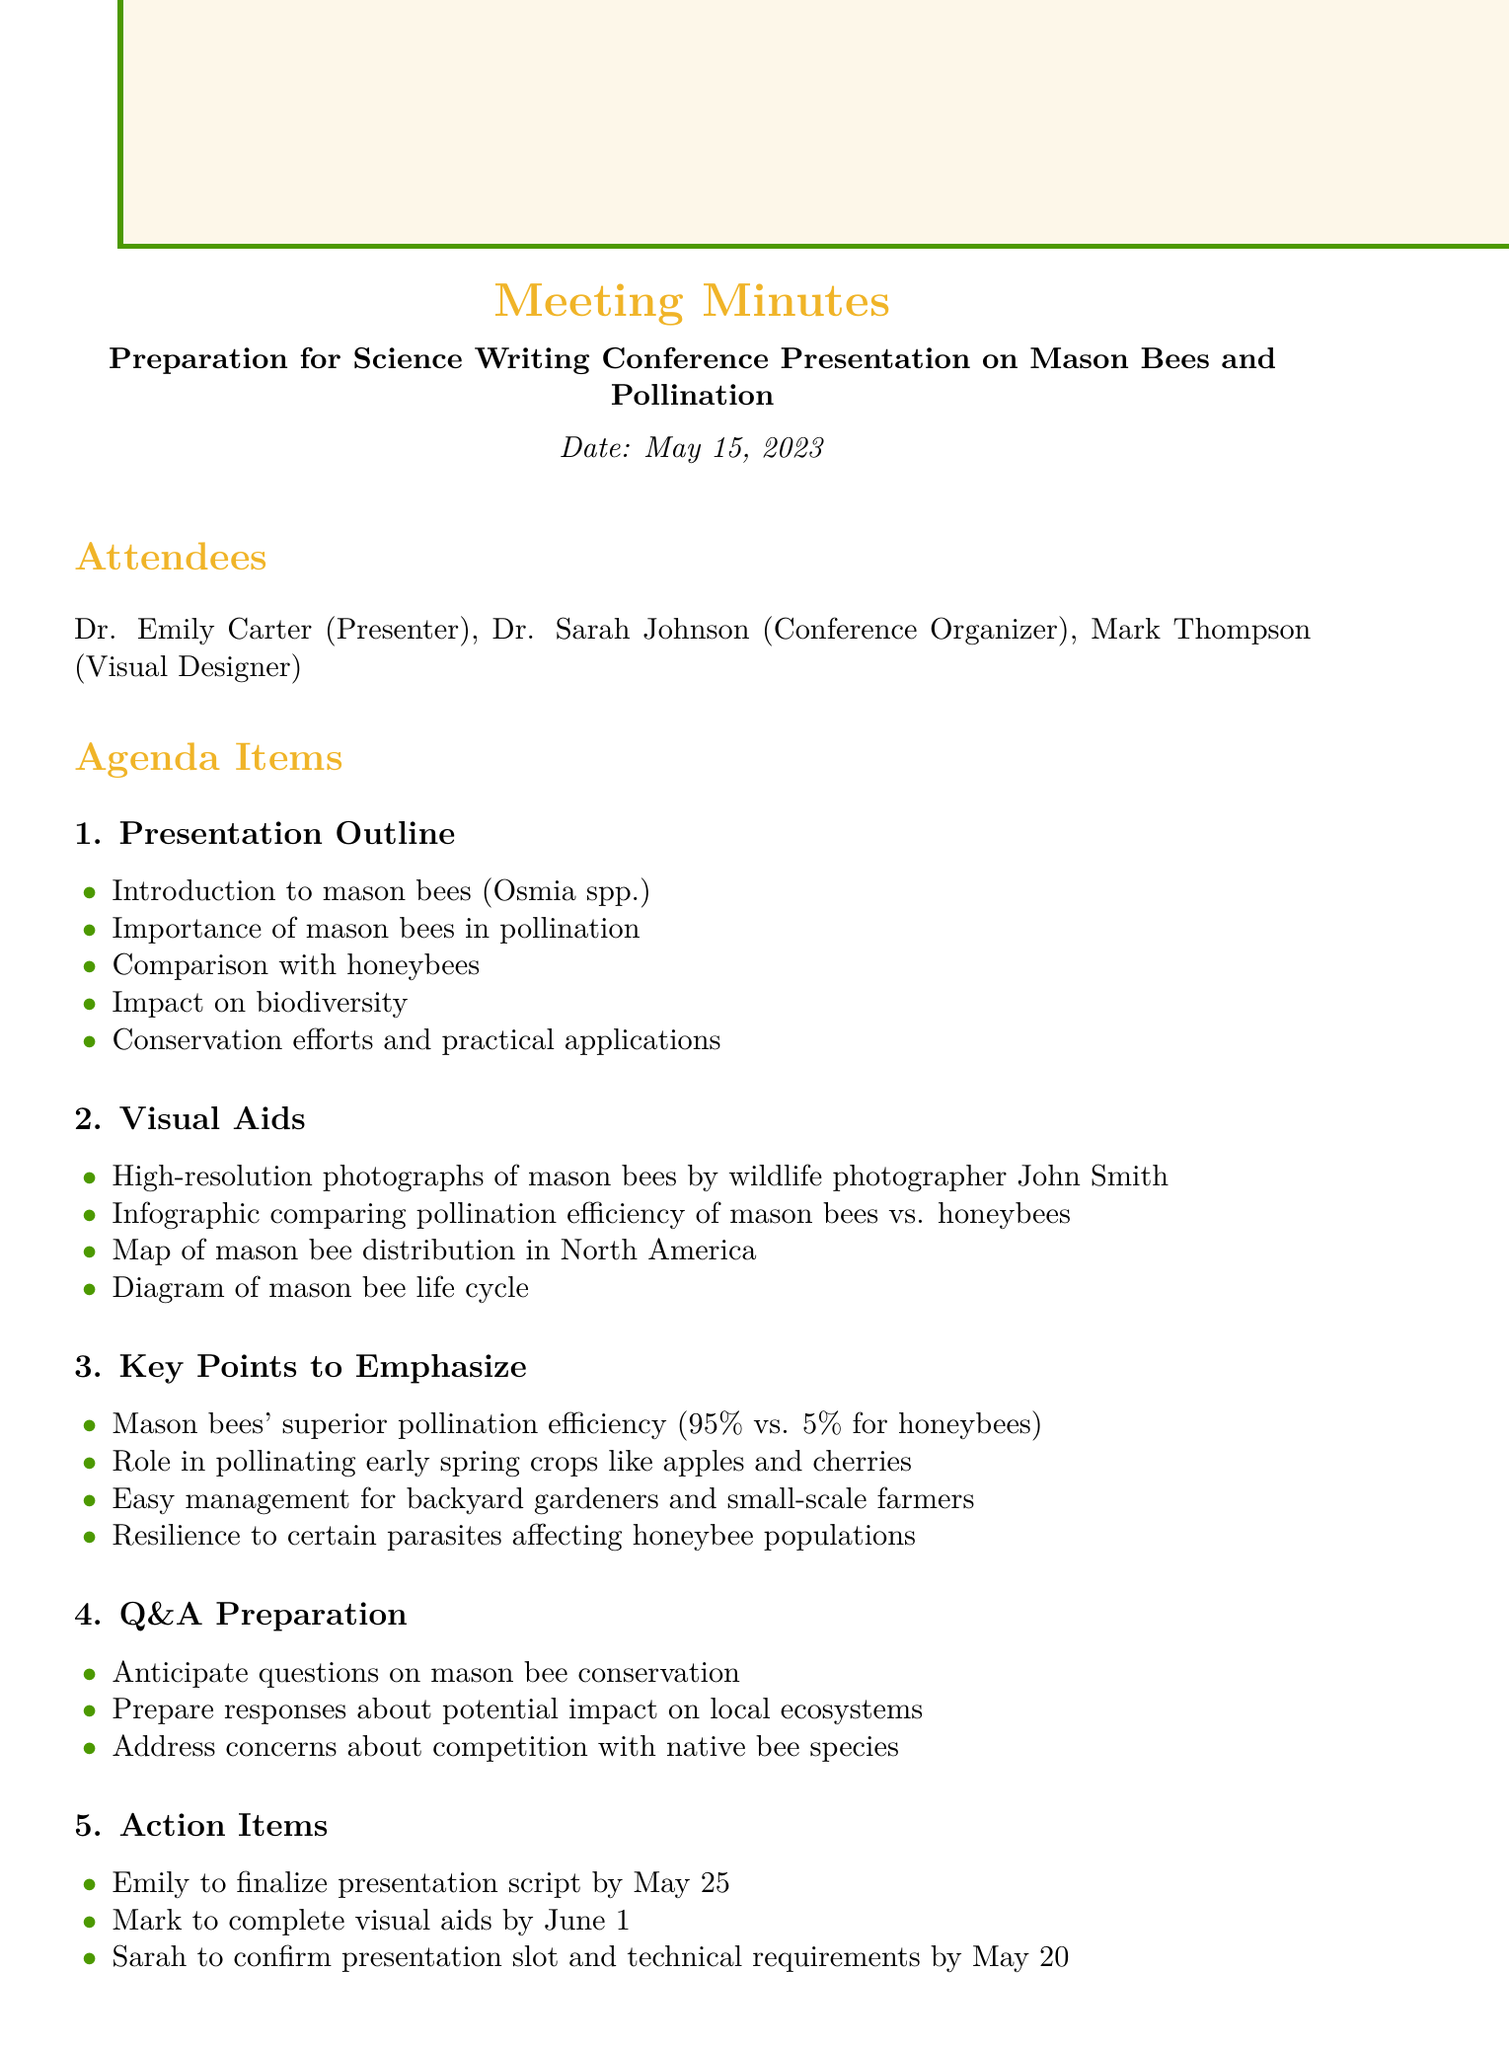What is the date of the meeting? The date of the meeting is explicitly mentioned in the document as May 15, 2023.
Answer: May 15, 2023 Who is responsible for completing the visual aids? The action item specifies that Mark is tasked with completing the visual aids by June 1.
Answer: Mark What percentage indicates the superior pollination efficiency of mason bees? The document states that mason bees have a superior pollination efficiency of 95 percent compared to honeybees.
Answer: 95% What is included in the presentation outline regarding mason bees? The presentation outline includes various topics, one being "Importance of mason bees in pollination."
Answer: Importance of mason bees in pollination What concern might be addressed during the Q&A session? The Q&A preparation outlines the need to address concerns about competition with native bee species.
Answer: Competition with native bee species When is the presentation script to be finalized? According to the action items, Emily is to finalize the presentation script by May 25.
Answer: May 25 What type of diagram will be included in the visual aids? The visual aids will include a diagram of the mason bee life cycle, as per the details provided.
Answer: Diagram of mason bee life cycle 